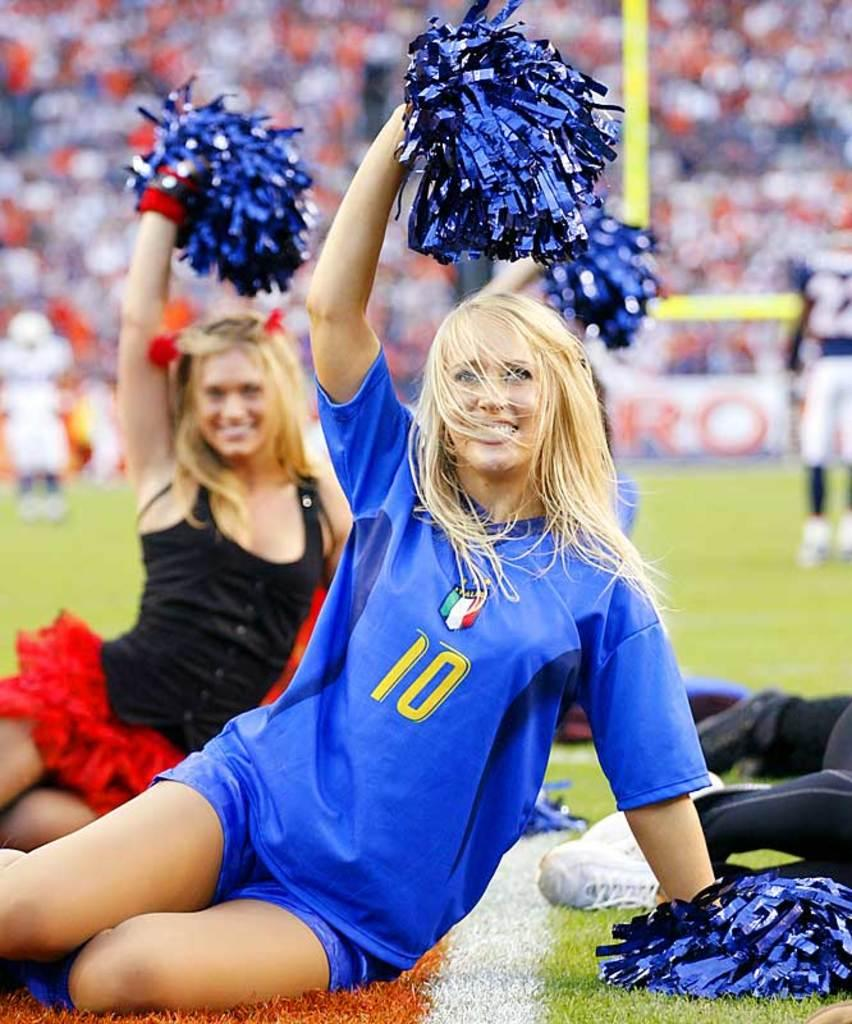<image>
Present a compact description of the photo's key features. Woman holding pom poms wearing a shirt that has the number 10. 